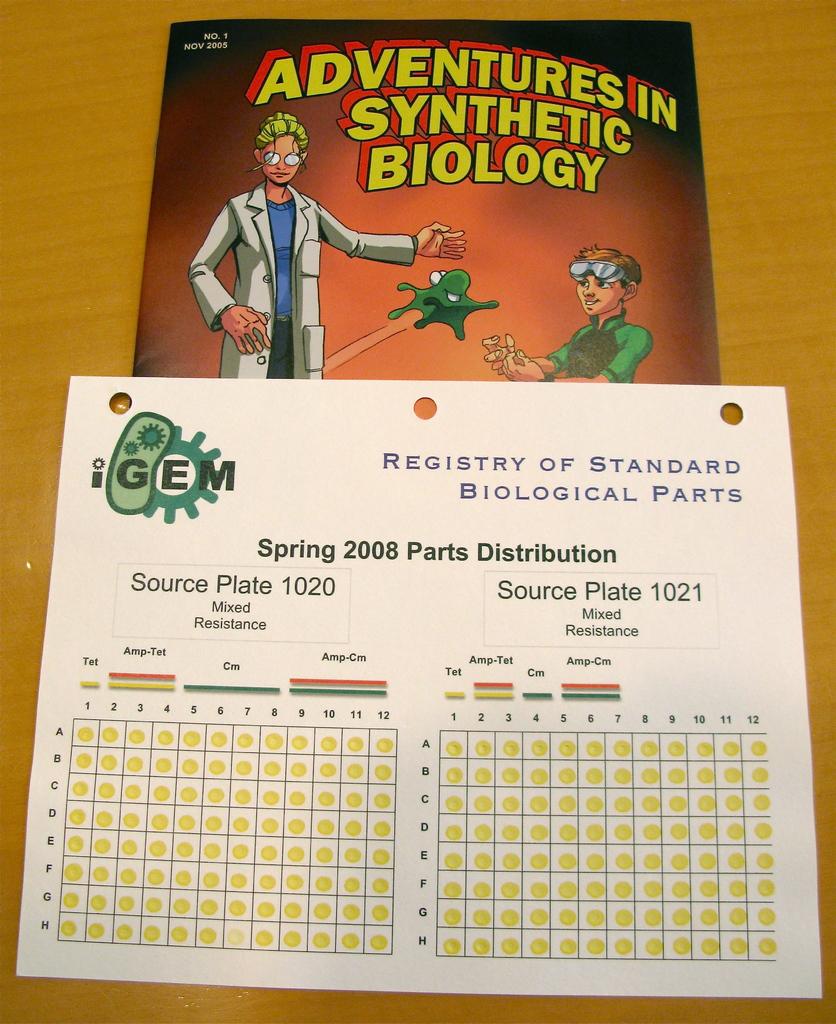What kind of adventures are mentioned here?
Offer a terse response. Synthetic biology. What year is printed?
Provide a short and direct response. 2008. 